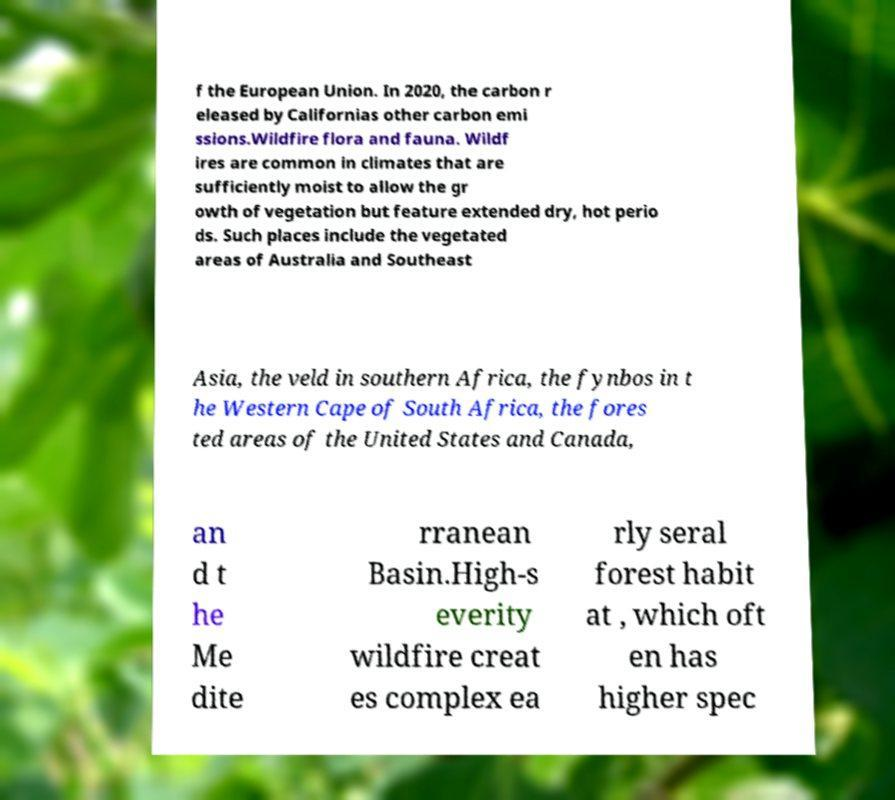I need the written content from this picture converted into text. Can you do that? f the European Union. In 2020, the carbon r eleased by Californias other carbon emi ssions.Wildfire flora and fauna. Wildf ires are common in climates that are sufficiently moist to allow the gr owth of vegetation but feature extended dry, hot perio ds. Such places include the vegetated areas of Australia and Southeast Asia, the veld in southern Africa, the fynbos in t he Western Cape of South Africa, the fores ted areas of the United States and Canada, an d t he Me dite rranean Basin.High-s everity wildfire creat es complex ea rly seral forest habit at , which oft en has higher spec 